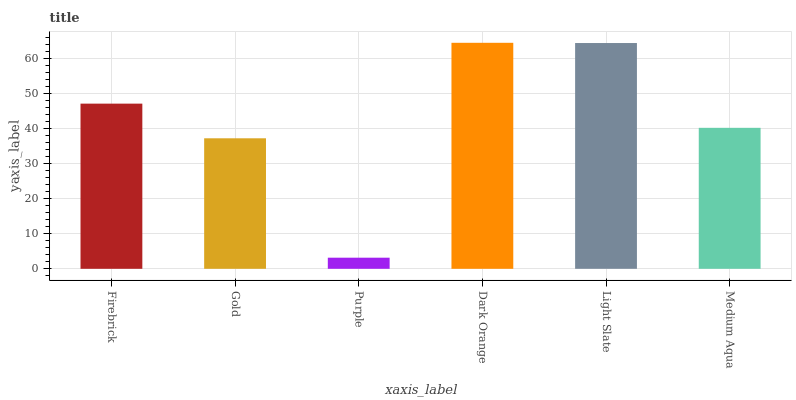Is Purple the minimum?
Answer yes or no. Yes. Is Dark Orange the maximum?
Answer yes or no. Yes. Is Gold the minimum?
Answer yes or no. No. Is Gold the maximum?
Answer yes or no. No. Is Firebrick greater than Gold?
Answer yes or no. Yes. Is Gold less than Firebrick?
Answer yes or no. Yes. Is Gold greater than Firebrick?
Answer yes or no. No. Is Firebrick less than Gold?
Answer yes or no. No. Is Firebrick the high median?
Answer yes or no. Yes. Is Medium Aqua the low median?
Answer yes or no. Yes. Is Medium Aqua the high median?
Answer yes or no. No. Is Gold the low median?
Answer yes or no. No. 